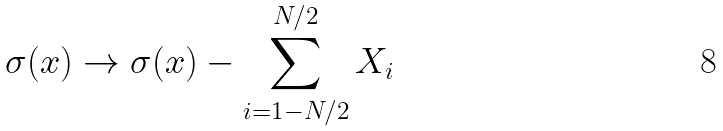Convert formula to latex. <formula><loc_0><loc_0><loc_500><loc_500>\sigma ( x ) \rightarrow \sigma ( x ) - \sum _ { i = 1 - N / 2 } ^ { N / 2 } X _ { i }</formula> 